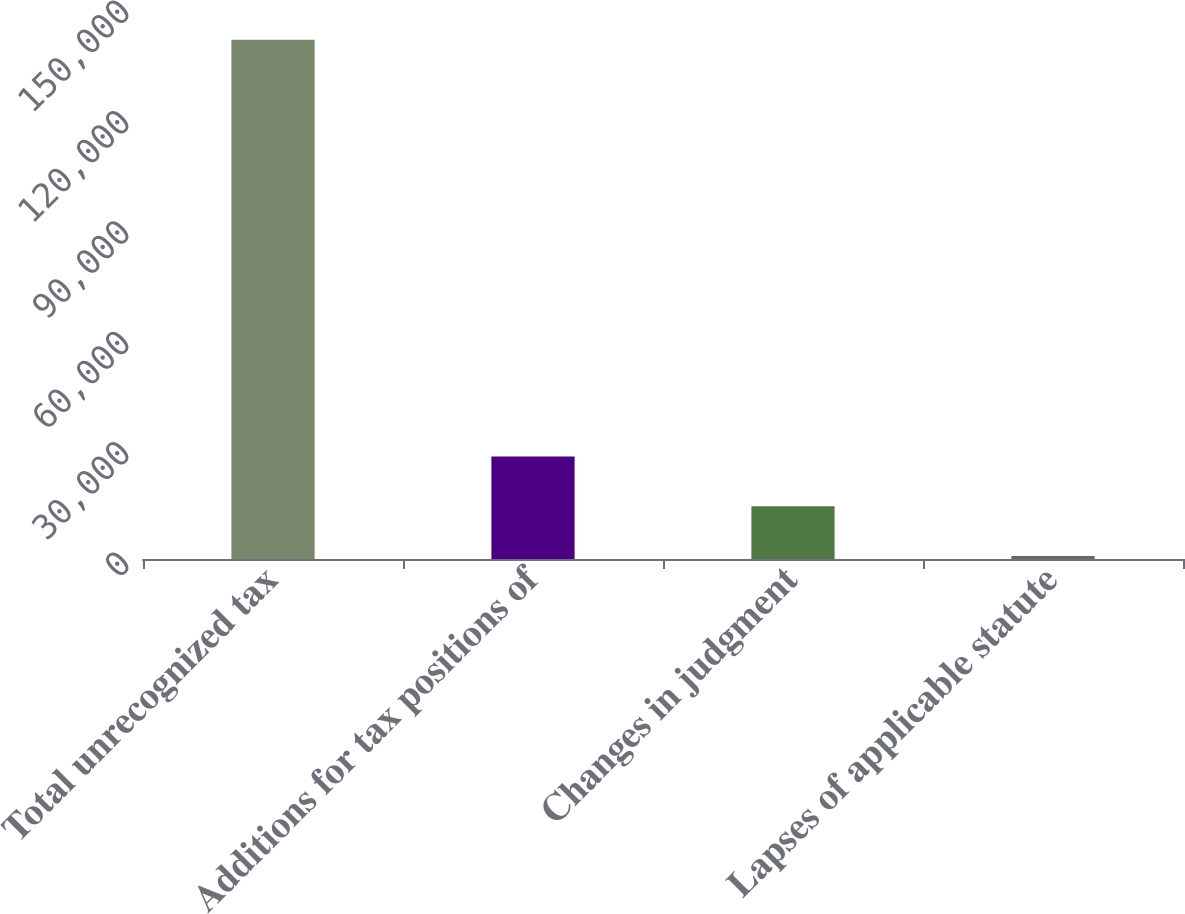Convert chart. <chart><loc_0><loc_0><loc_500><loc_500><bar_chart><fcel>Total unrecognized tax<fcel>Additions for tax positions of<fcel>Changes in judgment<fcel>Lapses of applicable statute<nl><fcel>141113<fcel>27861.8<fcel>14343.9<fcel>826<nl></chart> 